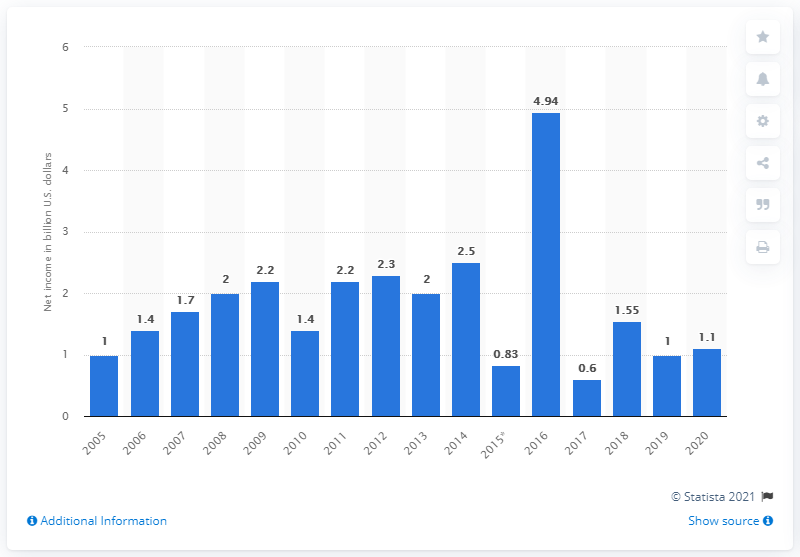Specify some key components in this picture. Baxter International reported net income of 1.1 billion USD in 2020. 